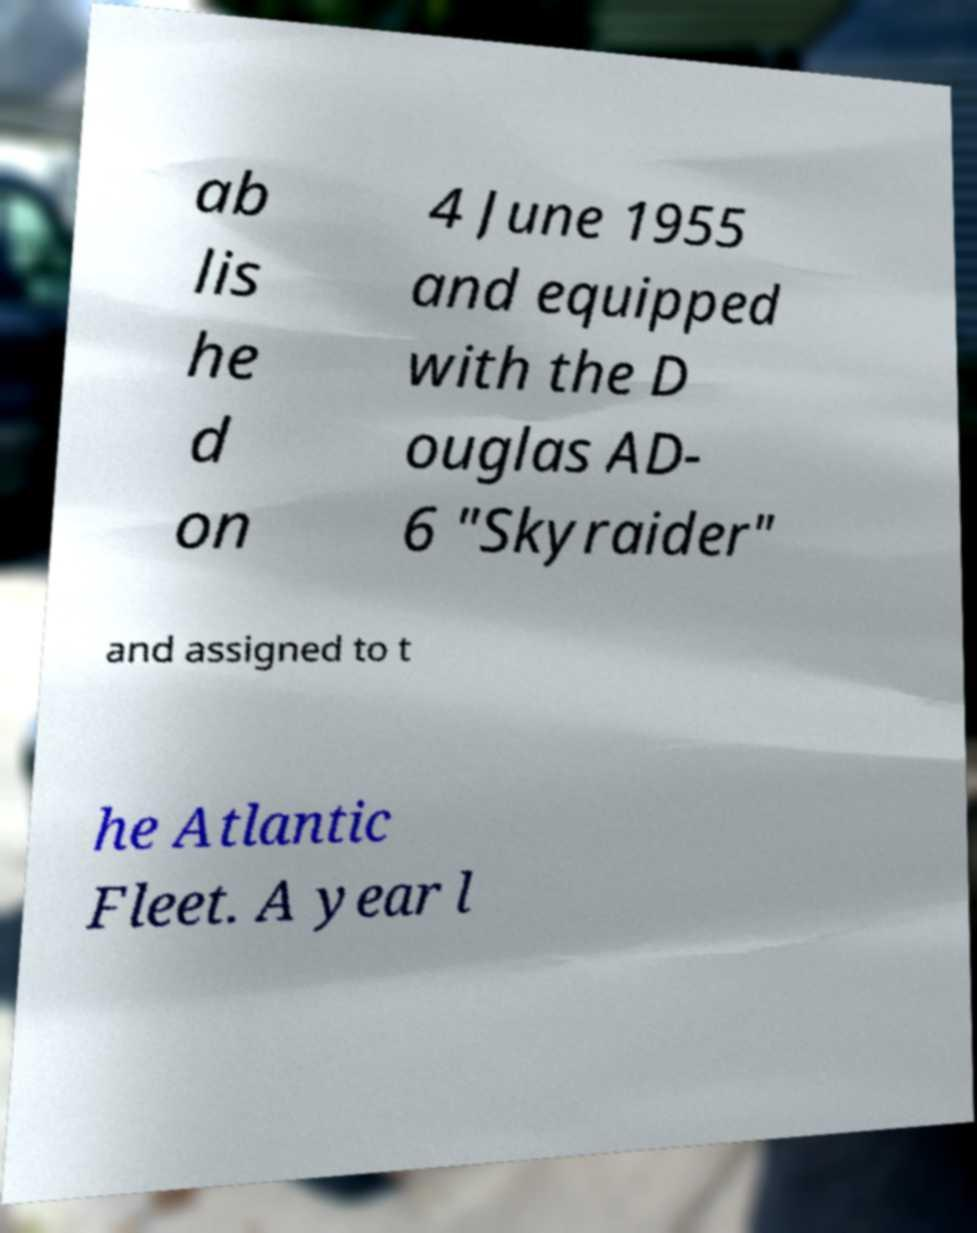Please read and relay the text visible in this image. What does it say? ab lis he d on 4 June 1955 and equipped with the D ouglas AD- 6 "Skyraider" and assigned to t he Atlantic Fleet. A year l 